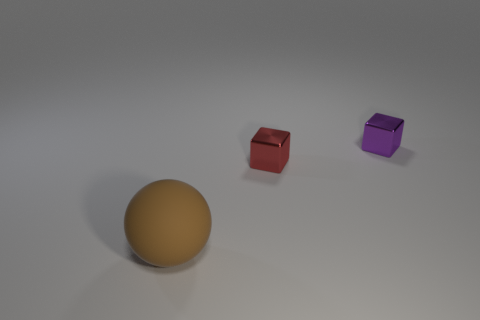Add 2 red objects. How many objects exist? 5 Subtract all balls. How many objects are left? 2 Add 1 small cubes. How many small cubes exist? 3 Subtract 0 yellow cubes. How many objects are left? 3 Subtract all large green objects. Subtract all tiny red blocks. How many objects are left? 2 Add 1 matte objects. How many matte objects are left? 2 